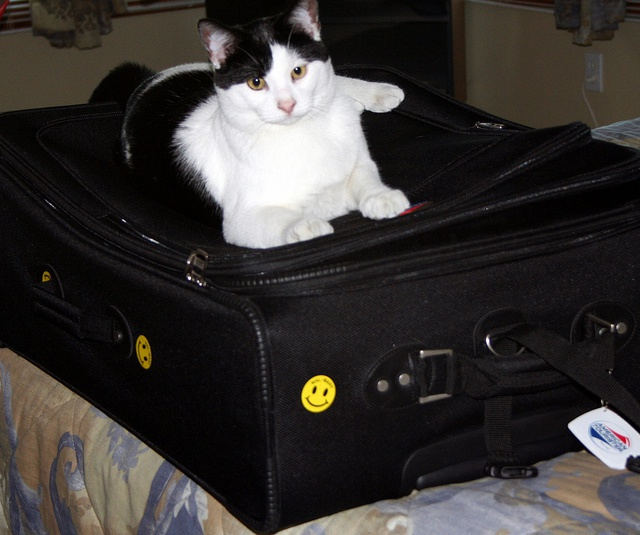Describe the objects in this image and their specific colors. I can see suitcase in black, gray, lightgray, and gold tones, cat in black, lightgray, darkgray, and gray tones, and bed in black, gray, and darkgray tones in this image. 